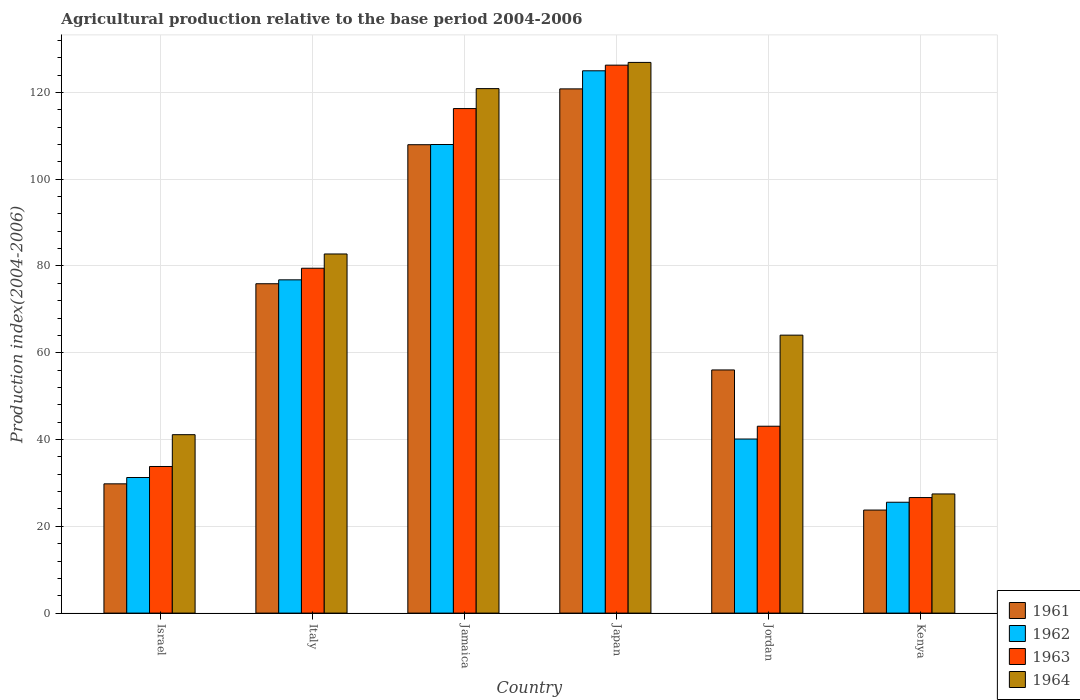How many different coloured bars are there?
Your answer should be very brief. 4. How many bars are there on the 1st tick from the left?
Your response must be concise. 4. How many bars are there on the 3rd tick from the right?
Give a very brief answer. 4. In how many cases, is the number of bars for a given country not equal to the number of legend labels?
Provide a succinct answer. 0. What is the agricultural production index in 1963 in Kenya?
Ensure brevity in your answer.  26.63. Across all countries, what is the maximum agricultural production index in 1963?
Your answer should be compact. 126.29. Across all countries, what is the minimum agricultural production index in 1964?
Your answer should be compact. 27.46. In which country was the agricultural production index in 1961 minimum?
Your answer should be very brief. Kenya. What is the total agricultural production index in 1964 in the graph?
Offer a very short reply. 463.21. What is the difference between the agricultural production index in 1961 in Israel and that in Jamaica?
Keep it short and to the point. -78.16. What is the difference between the agricultural production index in 1962 in Italy and the agricultural production index in 1963 in Jordan?
Make the answer very short. 33.74. What is the average agricultural production index in 1961 per country?
Provide a short and direct response. 69.04. What is the difference between the agricultural production index of/in 1962 and agricultural production index of/in 1963 in Japan?
Ensure brevity in your answer.  -1.3. What is the ratio of the agricultural production index in 1964 in Italy to that in Jamaica?
Your answer should be very brief. 0.68. Is the agricultural production index in 1962 in Jamaica less than that in Kenya?
Keep it short and to the point. No. Is the difference between the agricultural production index in 1962 in Jamaica and Japan greater than the difference between the agricultural production index in 1963 in Jamaica and Japan?
Offer a very short reply. No. What is the difference between the highest and the second highest agricultural production index in 1962?
Provide a succinct answer. -16.99. What is the difference between the highest and the lowest agricultural production index in 1964?
Offer a terse response. 99.46. In how many countries, is the agricultural production index in 1961 greater than the average agricultural production index in 1961 taken over all countries?
Ensure brevity in your answer.  3. Is the sum of the agricultural production index in 1963 in Japan and Kenya greater than the maximum agricultural production index in 1964 across all countries?
Provide a short and direct response. Yes. Is it the case that in every country, the sum of the agricultural production index in 1962 and agricultural production index in 1964 is greater than the sum of agricultural production index in 1961 and agricultural production index in 1963?
Ensure brevity in your answer.  No. What does the 4th bar from the right in Israel represents?
Ensure brevity in your answer.  1961. How many bars are there?
Offer a terse response. 24. Are all the bars in the graph horizontal?
Your answer should be very brief. No. How many countries are there in the graph?
Your answer should be very brief. 6. What is the difference between two consecutive major ticks on the Y-axis?
Your answer should be compact. 20. Does the graph contain any zero values?
Ensure brevity in your answer.  No. How many legend labels are there?
Provide a short and direct response. 4. How are the legend labels stacked?
Keep it short and to the point. Vertical. What is the title of the graph?
Provide a short and direct response. Agricultural production relative to the base period 2004-2006. Does "1970" appear as one of the legend labels in the graph?
Give a very brief answer. No. What is the label or title of the Y-axis?
Give a very brief answer. Production index(2004-2006). What is the Production index(2004-2006) in 1961 in Israel?
Offer a very short reply. 29.79. What is the Production index(2004-2006) of 1962 in Israel?
Your answer should be very brief. 31.25. What is the Production index(2004-2006) in 1963 in Israel?
Ensure brevity in your answer.  33.79. What is the Production index(2004-2006) of 1964 in Israel?
Provide a succinct answer. 41.12. What is the Production index(2004-2006) of 1961 in Italy?
Keep it short and to the point. 75.91. What is the Production index(2004-2006) in 1962 in Italy?
Offer a very short reply. 76.81. What is the Production index(2004-2006) in 1963 in Italy?
Offer a terse response. 79.48. What is the Production index(2004-2006) of 1964 in Italy?
Provide a short and direct response. 82.77. What is the Production index(2004-2006) in 1961 in Jamaica?
Your response must be concise. 107.95. What is the Production index(2004-2006) of 1962 in Jamaica?
Make the answer very short. 108. What is the Production index(2004-2006) in 1963 in Jamaica?
Your answer should be compact. 116.28. What is the Production index(2004-2006) in 1964 in Jamaica?
Provide a short and direct response. 120.88. What is the Production index(2004-2006) of 1961 in Japan?
Give a very brief answer. 120.82. What is the Production index(2004-2006) in 1962 in Japan?
Your answer should be compact. 124.99. What is the Production index(2004-2006) in 1963 in Japan?
Offer a terse response. 126.29. What is the Production index(2004-2006) of 1964 in Japan?
Give a very brief answer. 126.92. What is the Production index(2004-2006) of 1961 in Jordan?
Provide a succinct answer. 56.04. What is the Production index(2004-2006) in 1962 in Jordan?
Offer a very short reply. 40.12. What is the Production index(2004-2006) in 1963 in Jordan?
Ensure brevity in your answer.  43.07. What is the Production index(2004-2006) of 1964 in Jordan?
Make the answer very short. 64.06. What is the Production index(2004-2006) of 1961 in Kenya?
Provide a short and direct response. 23.75. What is the Production index(2004-2006) of 1962 in Kenya?
Offer a terse response. 25.55. What is the Production index(2004-2006) in 1963 in Kenya?
Offer a very short reply. 26.63. What is the Production index(2004-2006) of 1964 in Kenya?
Your response must be concise. 27.46. Across all countries, what is the maximum Production index(2004-2006) in 1961?
Your answer should be very brief. 120.82. Across all countries, what is the maximum Production index(2004-2006) of 1962?
Offer a very short reply. 124.99. Across all countries, what is the maximum Production index(2004-2006) of 1963?
Make the answer very short. 126.29. Across all countries, what is the maximum Production index(2004-2006) in 1964?
Give a very brief answer. 126.92. Across all countries, what is the minimum Production index(2004-2006) of 1961?
Your response must be concise. 23.75. Across all countries, what is the minimum Production index(2004-2006) of 1962?
Ensure brevity in your answer.  25.55. Across all countries, what is the minimum Production index(2004-2006) in 1963?
Keep it short and to the point. 26.63. Across all countries, what is the minimum Production index(2004-2006) of 1964?
Give a very brief answer. 27.46. What is the total Production index(2004-2006) of 1961 in the graph?
Your answer should be compact. 414.26. What is the total Production index(2004-2006) of 1962 in the graph?
Offer a terse response. 406.72. What is the total Production index(2004-2006) of 1963 in the graph?
Offer a very short reply. 425.54. What is the total Production index(2004-2006) in 1964 in the graph?
Make the answer very short. 463.21. What is the difference between the Production index(2004-2006) in 1961 in Israel and that in Italy?
Your response must be concise. -46.12. What is the difference between the Production index(2004-2006) of 1962 in Israel and that in Italy?
Offer a terse response. -45.56. What is the difference between the Production index(2004-2006) in 1963 in Israel and that in Italy?
Your answer should be very brief. -45.69. What is the difference between the Production index(2004-2006) in 1964 in Israel and that in Italy?
Provide a succinct answer. -41.65. What is the difference between the Production index(2004-2006) in 1961 in Israel and that in Jamaica?
Your response must be concise. -78.16. What is the difference between the Production index(2004-2006) in 1962 in Israel and that in Jamaica?
Offer a terse response. -76.75. What is the difference between the Production index(2004-2006) of 1963 in Israel and that in Jamaica?
Offer a terse response. -82.49. What is the difference between the Production index(2004-2006) of 1964 in Israel and that in Jamaica?
Provide a succinct answer. -79.76. What is the difference between the Production index(2004-2006) in 1961 in Israel and that in Japan?
Give a very brief answer. -91.03. What is the difference between the Production index(2004-2006) of 1962 in Israel and that in Japan?
Give a very brief answer. -93.74. What is the difference between the Production index(2004-2006) of 1963 in Israel and that in Japan?
Give a very brief answer. -92.5. What is the difference between the Production index(2004-2006) of 1964 in Israel and that in Japan?
Provide a succinct answer. -85.8. What is the difference between the Production index(2004-2006) in 1961 in Israel and that in Jordan?
Ensure brevity in your answer.  -26.25. What is the difference between the Production index(2004-2006) in 1962 in Israel and that in Jordan?
Keep it short and to the point. -8.87. What is the difference between the Production index(2004-2006) of 1963 in Israel and that in Jordan?
Provide a short and direct response. -9.28. What is the difference between the Production index(2004-2006) in 1964 in Israel and that in Jordan?
Your response must be concise. -22.94. What is the difference between the Production index(2004-2006) in 1961 in Israel and that in Kenya?
Ensure brevity in your answer.  6.04. What is the difference between the Production index(2004-2006) in 1963 in Israel and that in Kenya?
Your response must be concise. 7.16. What is the difference between the Production index(2004-2006) in 1964 in Israel and that in Kenya?
Offer a terse response. 13.66. What is the difference between the Production index(2004-2006) of 1961 in Italy and that in Jamaica?
Ensure brevity in your answer.  -32.04. What is the difference between the Production index(2004-2006) of 1962 in Italy and that in Jamaica?
Provide a succinct answer. -31.19. What is the difference between the Production index(2004-2006) in 1963 in Italy and that in Jamaica?
Provide a succinct answer. -36.8. What is the difference between the Production index(2004-2006) in 1964 in Italy and that in Jamaica?
Your answer should be compact. -38.11. What is the difference between the Production index(2004-2006) of 1961 in Italy and that in Japan?
Provide a succinct answer. -44.91. What is the difference between the Production index(2004-2006) of 1962 in Italy and that in Japan?
Your answer should be very brief. -48.18. What is the difference between the Production index(2004-2006) in 1963 in Italy and that in Japan?
Offer a terse response. -46.81. What is the difference between the Production index(2004-2006) of 1964 in Italy and that in Japan?
Keep it short and to the point. -44.15. What is the difference between the Production index(2004-2006) of 1961 in Italy and that in Jordan?
Your response must be concise. 19.87. What is the difference between the Production index(2004-2006) of 1962 in Italy and that in Jordan?
Offer a very short reply. 36.69. What is the difference between the Production index(2004-2006) in 1963 in Italy and that in Jordan?
Your response must be concise. 36.41. What is the difference between the Production index(2004-2006) in 1964 in Italy and that in Jordan?
Your answer should be very brief. 18.71. What is the difference between the Production index(2004-2006) in 1961 in Italy and that in Kenya?
Give a very brief answer. 52.16. What is the difference between the Production index(2004-2006) in 1962 in Italy and that in Kenya?
Your response must be concise. 51.26. What is the difference between the Production index(2004-2006) in 1963 in Italy and that in Kenya?
Provide a short and direct response. 52.85. What is the difference between the Production index(2004-2006) of 1964 in Italy and that in Kenya?
Your answer should be very brief. 55.31. What is the difference between the Production index(2004-2006) of 1961 in Jamaica and that in Japan?
Provide a succinct answer. -12.87. What is the difference between the Production index(2004-2006) of 1962 in Jamaica and that in Japan?
Your answer should be very brief. -16.99. What is the difference between the Production index(2004-2006) of 1963 in Jamaica and that in Japan?
Give a very brief answer. -10.01. What is the difference between the Production index(2004-2006) of 1964 in Jamaica and that in Japan?
Your answer should be compact. -6.04. What is the difference between the Production index(2004-2006) of 1961 in Jamaica and that in Jordan?
Give a very brief answer. 51.91. What is the difference between the Production index(2004-2006) of 1962 in Jamaica and that in Jordan?
Keep it short and to the point. 67.88. What is the difference between the Production index(2004-2006) in 1963 in Jamaica and that in Jordan?
Keep it short and to the point. 73.21. What is the difference between the Production index(2004-2006) in 1964 in Jamaica and that in Jordan?
Ensure brevity in your answer.  56.82. What is the difference between the Production index(2004-2006) of 1961 in Jamaica and that in Kenya?
Provide a short and direct response. 84.2. What is the difference between the Production index(2004-2006) in 1962 in Jamaica and that in Kenya?
Ensure brevity in your answer.  82.45. What is the difference between the Production index(2004-2006) in 1963 in Jamaica and that in Kenya?
Keep it short and to the point. 89.65. What is the difference between the Production index(2004-2006) in 1964 in Jamaica and that in Kenya?
Your response must be concise. 93.42. What is the difference between the Production index(2004-2006) in 1961 in Japan and that in Jordan?
Your answer should be compact. 64.78. What is the difference between the Production index(2004-2006) of 1962 in Japan and that in Jordan?
Ensure brevity in your answer.  84.87. What is the difference between the Production index(2004-2006) of 1963 in Japan and that in Jordan?
Provide a short and direct response. 83.22. What is the difference between the Production index(2004-2006) in 1964 in Japan and that in Jordan?
Keep it short and to the point. 62.86. What is the difference between the Production index(2004-2006) in 1961 in Japan and that in Kenya?
Offer a very short reply. 97.07. What is the difference between the Production index(2004-2006) in 1962 in Japan and that in Kenya?
Give a very brief answer. 99.44. What is the difference between the Production index(2004-2006) in 1963 in Japan and that in Kenya?
Offer a terse response. 99.66. What is the difference between the Production index(2004-2006) of 1964 in Japan and that in Kenya?
Ensure brevity in your answer.  99.46. What is the difference between the Production index(2004-2006) in 1961 in Jordan and that in Kenya?
Your answer should be very brief. 32.29. What is the difference between the Production index(2004-2006) in 1962 in Jordan and that in Kenya?
Offer a terse response. 14.57. What is the difference between the Production index(2004-2006) in 1963 in Jordan and that in Kenya?
Offer a terse response. 16.44. What is the difference between the Production index(2004-2006) of 1964 in Jordan and that in Kenya?
Make the answer very short. 36.6. What is the difference between the Production index(2004-2006) in 1961 in Israel and the Production index(2004-2006) in 1962 in Italy?
Offer a very short reply. -47.02. What is the difference between the Production index(2004-2006) in 1961 in Israel and the Production index(2004-2006) in 1963 in Italy?
Provide a short and direct response. -49.69. What is the difference between the Production index(2004-2006) of 1961 in Israel and the Production index(2004-2006) of 1964 in Italy?
Your answer should be compact. -52.98. What is the difference between the Production index(2004-2006) of 1962 in Israel and the Production index(2004-2006) of 1963 in Italy?
Your answer should be very brief. -48.23. What is the difference between the Production index(2004-2006) in 1962 in Israel and the Production index(2004-2006) in 1964 in Italy?
Offer a very short reply. -51.52. What is the difference between the Production index(2004-2006) of 1963 in Israel and the Production index(2004-2006) of 1964 in Italy?
Your answer should be compact. -48.98. What is the difference between the Production index(2004-2006) in 1961 in Israel and the Production index(2004-2006) in 1962 in Jamaica?
Your answer should be compact. -78.21. What is the difference between the Production index(2004-2006) in 1961 in Israel and the Production index(2004-2006) in 1963 in Jamaica?
Keep it short and to the point. -86.49. What is the difference between the Production index(2004-2006) in 1961 in Israel and the Production index(2004-2006) in 1964 in Jamaica?
Ensure brevity in your answer.  -91.09. What is the difference between the Production index(2004-2006) of 1962 in Israel and the Production index(2004-2006) of 1963 in Jamaica?
Give a very brief answer. -85.03. What is the difference between the Production index(2004-2006) in 1962 in Israel and the Production index(2004-2006) in 1964 in Jamaica?
Offer a terse response. -89.63. What is the difference between the Production index(2004-2006) in 1963 in Israel and the Production index(2004-2006) in 1964 in Jamaica?
Make the answer very short. -87.09. What is the difference between the Production index(2004-2006) in 1961 in Israel and the Production index(2004-2006) in 1962 in Japan?
Provide a succinct answer. -95.2. What is the difference between the Production index(2004-2006) in 1961 in Israel and the Production index(2004-2006) in 1963 in Japan?
Your response must be concise. -96.5. What is the difference between the Production index(2004-2006) of 1961 in Israel and the Production index(2004-2006) of 1964 in Japan?
Your answer should be very brief. -97.13. What is the difference between the Production index(2004-2006) in 1962 in Israel and the Production index(2004-2006) in 1963 in Japan?
Provide a succinct answer. -95.04. What is the difference between the Production index(2004-2006) in 1962 in Israel and the Production index(2004-2006) in 1964 in Japan?
Provide a succinct answer. -95.67. What is the difference between the Production index(2004-2006) of 1963 in Israel and the Production index(2004-2006) of 1964 in Japan?
Provide a succinct answer. -93.13. What is the difference between the Production index(2004-2006) of 1961 in Israel and the Production index(2004-2006) of 1962 in Jordan?
Your response must be concise. -10.33. What is the difference between the Production index(2004-2006) of 1961 in Israel and the Production index(2004-2006) of 1963 in Jordan?
Offer a terse response. -13.28. What is the difference between the Production index(2004-2006) in 1961 in Israel and the Production index(2004-2006) in 1964 in Jordan?
Your response must be concise. -34.27. What is the difference between the Production index(2004-2006) of 1962 in Israel and the Production index(2004-2006) of 1963 in Jordan?
Provide a short and direct response. -11.82. What is the difference between the Production index(2004-2006) in 1962 in Israel and the Production index(2004-2006) in 1964 in Jordan?
Provide a short and direct response. -32.81. What is the difference between the Production index(2004-2006) in 1963 in Israel and the Production index(2004-2006) in 1964 in Jordan?
Your answer should be compact. -30.27. What is the difference between the Production index(2004-2006) in 1961 in Israel and the Production index(2004-2006) in 1962 in Kenya?
Give a very brief answer. 4.24. What is the difference between the Production index(2004-2006) of 1961 in Israel and the Production index(2004-2006) of 1963 in Kenya?
Make the answer very short. 3.16. What is the difference between the Production index(2004-2006) in 1961 in Israel and the Production index(2004-2006) in 1964 in Kenya?
Your answer should be very brief. 2.33. What is the difference between the Production index(2004-2006) in 1962 in Israel and the Production index(2004-2006) in 1963 in Kenya?
Your response must be concise. 4.62. What is the difference between the Production index(2004-2006) of 1962 in Israel and the Production index(2004-2006) of 1964 in Kenya?
Ensure brevity in your answer.  3.79. What is the difference between the Production index(2004-2006) in 1963 in Israel and the Production index(2004-2006) in 1964 in Kenya?
Keep it short and to the point. 6.33. What is the difference between the Production index(2004-2006) of 1961 in Italy and the Production index(2004-2006) of 1962 in Jamaica?
Your answer should be very brief. -32.09. What is the difference between the Production index(2004-2006) of 1961 in Italy and the Production index(2004-2006) of 1963 in Jamaica?
Your answer should be very brief. -40.37. What is the difference between the Production index(2004-2006) in 1961 in Italy and the Production index(2004-2006) in 1964 in Jamaica?
Your response must be concise. -44.97. What is the difference between the Production index(2004-2006) in 1962 in Italy and the Production index(2004-2006) in 1963 in Jamaica?
Offer a very short reply. -39.47. What is the difference between the Production index(2004-2006) of 1962 in Italy and the Production index(2004-2006) of 1964 in Jamaica?
Provide a succinct answer. -44.07. What is the difference between the Production index(2004-2006) of 1963 in Italy and the Production index(2004-2006) of 1964 in Jamaica?
Give a very brief answer. -41.4. What is the difference between the Production index(2004-2006) in 1961 in Italy and the Production index(2004-2006) in 1962 in Japan?
Give a very brief answer. -49.08. What is the difference between the Production index(2004-2006) of 1961 in Italy and the Production index(2004-2006) of 1963 in Japan?
Your response must be concise. -50.38. What is the difference between the Production index(2004-2006) of 1961 in Italy and the Production index(2004-2006) of 1964 in Japan?
Your answer should be compact. -51.01. What is the difference between the Production index(2004-2006) of 1962 in Italy and the Production index(2004-2006) of 1963 in Japan?
Provide a succinct answer. -49.48. What is the difference between the Production index(2004-2006) in 1962 in Italy and the Production index(2004-2006) in 1964 in Japan?
Provide a short and direct response. -50.11. What is the difference between the Production index(2004-2006) of 1963 in Italy and the Production index(2004-2006) of 1964 in Japan?
Give a very brief answer. -47.44. What is the difference between the Production index(2004-2006) of 1961 in Italy and the Production index(2004-2006) of 1962 in Jordan?
Give a very brief answer. 35.79. What is the difference between the Production index(2004-2006) in 1961 in Italy and the Production index(2004-2006) in 1963 in Jordan?
Provide a short and direct response. 32.84. What is the difference between the Production index(2004-2006) in 1961 in Italy and the Production index(2004-2006) in 1964 in Jordan?
Offer a terse response. 11.85. What is the difference between the Production index(2004-2006) in 1962 in Italy and the Production index(2004-2006) in 1963 in Jordan?
Your response must be concise. 33.74. What is the difference between the Production index(2004-2006) in 1962 in Italy and the Production index(2004-2006) in 1964 in Jordan?
Provide a short and direct response. 12.75. What is the difference between the Production index(2004-2006) in 1963 in Italy and the Production index(2004-2006) in 1964 in Jordan?
Provide a short and direct response. 15.42. What is the difference between the Production index(2004-2006) in 1961 in Italy and the Production index(2004-2006) in 1962 in Kenya?
Ensure brevity in your answer.  50.36. What is the difference between the Production index(2004-2006) of 1961 in Italy and the Production index(2004-2006) of 1963 in Kenya?
Offer a very short reply. 49.28. What is the difference between the Production index(2004-2006) in 1961 in Italy and the Production index(2004-2006) in 1964 in Kenya?
Your response must be concise. 48.45. What is the difference between the Production index(2004-2006) in 1962 in Italy and the Production index(2004-2006) in 1963 in Kenya?
Ensure brevity in your answer.  50.18. What is the difference between the Production index(2004-2006) in 1962 in Italy and the Production index(2004-2006) in 1964 in Kenya?
Give a very brief answer. 49.35. What is the difference between the Production index(2004-2006) of 1963 in Italy and the Production index(2004-2006) of 1964 in Kenya?
Provide a short and direct response. 52.02. What is the difference between the Production index(2004-2006) of 1961 in Jamaica and the Production index(2004-2006) of 1962 in Japan?
Make the answer very short. -17.04. What is the difference between the Production index(2004-2006) of 1961 in Jamaica and the Production index(2004-2006) of 1963 in Japan?
Give a very brief answer. -18.34. What is the difference between the Production index(2004-2006) of 1961 in Jamaica and the Production index(2004-2006) of 1964 in Japan?
Offer a terse response. -18.97. What is the difference between the Production index(2004-2006) in 1962 in Jamaica and the Production index(2004-2006) in 1963 in Japan?
Your answer should be compact. -18.29. What is the difference between the Production index(2004-2006) in 1962 in Jamaica and the Production index(2004-2006) in 1964 in Japan?
Your answer should be compact. -18.92. What is the difference between the Production index(2004-2006) in 1963 in Jamaica and the Production index(2004-2006) in 1964 in Japan?
Offer a terse response. -10.64. What is the difference between the Production index(2004-2006) of 1961 in Jamaica and the Production index(2004-2006) of 1962 in Jordan?
Ensure brevity in your answer.  67.83. What is the difference between the Production index(2004-2006) in 1961 in Jamaica and the Production index(2004-2006) in 1963 in Jordan?
Ensure brevity in your answer.  64.88. What is the difference between the Production index(2004-2006) of 1961 in Jamaica and the Production index(2004-2006) of 1964 in Jordan?
Provide a short and direct response. 43.89. What is the difference between the Production index(2004-2006) of 1962 in Jamaica and the Production index(2004-2006) of 1963 in Jordan?
Offer a very short reply. 64.93. What is the difference between the Production index(2004-2006) in 1962 in Jamaica and the Production index(2004-2006) in 1964 in Jordan?
Make the answer very short. 43.94. What is the difference between the Production index(2004-2006) in 1963 in Jamaica and the Production index(2004-2006) in 1964 in Jordan?
Your answer should be very brief. 52.22. What is the difference between the Production index(2004-2006) in 1961 in Jamaica and the Production index(2004-2006) in 1962 in Kenya?
Offer a terse response. 82.4. What is the difference between the Production index(2004-2006) in 1961 in Jamaica and the Production index(2004-2006) in 1963 in Kenya?
Keep it short and to the point. 81.32. What is the difference between the Production index(2004-2006) in 1961 in Jamaica and the Production index(2004-2006) in 1964 in Kenya?
Your response must be concise. 80.49. What is the difference between the Production index(2004-2006) in 1962 in Jamaica and the Production index(2004-2006) in 1963 in Kenya?
Your answer should be compact. 81.37. What is the difference between the Production index(2004-2006) of 1962 in Jamaica and the Production index(2004-2006) of 1964 in Kenya?
Your answer should be compact. 80.54. What is the difference between the Production index(2004-2006) in 1963 in Jamaica and the Production index(2004-2006) in 1964 in Kenya?
Provide a short and direct response. 88.82. What is the difference between the Production index(2004-2006) of 1961 in Japan and the Production index(2004-2006) of 1962 in Jordan?
Give a very brief answer. 80.7. What is the difference between the Production index(2004-2006) in 1961 in Japan and the Production index(2004-2006) in 1963 in Jordan?
Offer a terse response. 77.75. What is the difference between the Production index(2004-2006) of 1961 in Japan and the Production index(2004-2006) of 1964 in Jordan?
Provide a short and direct response. 56.76. What is the difference between the Production index(2004-2006) in 1962 in Japan and the Production index(2004-2006) in 1963 in Jordan?
Offer a terse response. 81.92. What is the difference between the Production index(2004-2006) in 1962 in Japan and the Production index(2004-2006) in 1964 in Jordan?
Provide a short and direct response. 60.93. What is the difference between the Production index(2004-2006) of 1963 in Japan and the Production index(2004-2006) of 1964 in Jordan?
Make the answer very short. 62.23. What is the difference between the Production index(2004-2006) of 1961 in Japan and the Production index(2004-2006) of 1962 in Kenya?
Your answer should be very brief. 95.27. What is the difference between the Production index(2004-2006) of 1961 in Japan and the Production index(2004-2006) of 1963 in Kenya?
Your response must be concise. 94.19. What is the difference between the Production index(2004-2006) in 1961 in Japan and the Production index(2004-2006) in 1964 in Kenya?
Your response must be concise. 93.36. What is the difference between the Production index(2004-2006) of 1962 in Japan and the Production index(2004-2006) of 1963 in Kenya?
Keep it short and to the point. 98.36. What is the difference between the Production index(2004-2006) of 1962 in Japan and the Production index(2004-2006) of 1964 in Kenya?
Provide a succinct answer. 97.53. What is the difference between the Production index(2004-2006) of 1963 in Japan and the Production index(2004-2006) of 1964 in Kenya?
Your answer should be compact. 98.83. What is the difference between the Production index(2004-2006) of 1961 in Jordan and the Production index(2004-2006) of 1962 in Kenya?
Provide a succinct answer. 30.49. What is the difference between the Production index(2004-2006) of 1961 in Jordan and the Production index(2004-2006) of 1963 in Kenya?
Give a very brief answer. 29.41. What is the difference between the Production index(2004-2006) of 1961 in Jordan and the Production index(2004-2006) of 1964 in Kenya?
Keep it short and to the point. 28.58. What is the difference between the Production index(2004-2006) of 1962 in Jordan and the Production index(2004-2006) of 1963 in Kenya?
Offer a very short reply. 13.49. What is the difference between the Production index(2004-2006) in 1962 in Jordan and the Production index(2004-2006) in 1964 in Kenya?
Your answer should be very brief. 12.66. What is the difference between the Production index(2004-2006) in 1963 in Jordan and the Production index(2004-2006) in 1964 in Kenya?
Make the answer very short. 15.61. What is the average Production index(2004-2006) in 1961 per country?
Make the answer very short. 69.04. What is the average Production index(2004-2006) in 1962 per country?
Provide a succinct answer. 67.79. What is the average Production index(2004-2006) of 1963 per country?
Offer a terse response. 70.92. What is the average Production index(2004-2006) of 1964 per country?
Offer a very short reply. 77.2. What is the difference between the Production index(2004-2006) of 1961 and Production index(2004-2006) of 1962 in Israel?
Your response must be concise. -1.46. What is the difference between the Production index(2004-2006) of 1961 and Production index(2004-2006) of 1963 in Israel?
Your answer should be very brief. -4. What is the difference between the Production index(2004-2006) of 1961 and Production index(2004-2006) of 1964 in Israel?
Your answer should be compact. -11.33. What is the difference between the Production index(2004-2006) in 1962 and Production index(2004-2006) in 1963 in Israel?
Make the answer very short. -2.54. What is the difference between the Production index(2004-2006) in 1962 and Production index(2004-2006) in 1964 in Israel?
Ensure brevity in your answer.  -9.87. What is the difference between the Production index(2004-2006) in 1963 and Production index(2004-2006) in 1964 in Israel?
Provide a succinct answer. -7.33. What is the difference between the Production index(2004-2006) of 1961 and Production index(2004-2006) of 1963 in Italy?
Offer a very short reply. -3.57. What is the difference between the Production index(2004-2006) of 1961 and Production index(2004-2006) of 1964 in Italy?
Make the answer very short. -6.86. What is the difference between the Production index(2004-2006) in 1962 and Production index(2004-2006) in 1963 in Italy?
Provide a succinct answer. -2.67. What is the difference between the Production index(2004-2006) in 1962 and Production index(2004-2006) in 1964 in Italy?
Offer a very short reply. -5.96. What is the difference between the Production index(2004-2006) of 1963 and Production index(2004-2006) of 1964 in Italy?
Make the answer very short. -3.29. What is the difference between the Production index(2004-2006) in 1961 and Production index(2004-2006) in 1962 in Jamaica?
Provide a succinct answer. -0.05. What is the difference between the Production index(2004-2006) in 1961 and Production index(2004-2006) in 1963 in Jamaica?
Your answer should be compact. -8.33. What is the difference between the Production index(2004-2006) in 1961 and Production index(2004-2006) in 1964 in Jamaica?
Your response must be concise. -12.93. What is the difference between the Production index(2004-2006) in 1962 and Production index(2004-2006) in 1963 in Jamaica?
Offer a very short reply. -8.28. What is the difference between the Production index(2004-2006) of 1962 and Production index(2004-2006) of 1964 in Jamaica?
Your response must be concise. -12.88. What is the difference between the Production index(2004-2006) of 1961 and Production index(2004-2006) of 1962 in Japan?
Your answer should be compact. -4.17. What is the difference between the Production index(2004-2006) of 1961 and Production index(2004-2006) of 1963 in Japan?
Provide a succinct answer. -5.47. What is the difference between the Production index(2004-2006) of 1961 and Production index(2004-2006) of 1964 in Japan?
Your response must be concise. -6.1. What is the difference between the Production index(2004-2006) in 1962 and Production index(2004-2006) in 1964 in Japan?
Offer a terse response. -1.93. What is the difference between the Production index(2004-2006) in 1963 and Production index(2004-2006) in 1964 in Japan?
Offer a terse response. -0.63. What is the difference between the Production index(2004-2006) in 1961 and Production index(2004-2006) in 1962 in Jordan?
Your answer should be compact. 15.92. What is the difference between the Production index(2004-2006) of 1961 and Production index(2004-2006) of 1963 in Jordan?
Your answer should be very brief. 12.97. What is the difference between the Production index(2004-2006) of 1961 and Production index(2004-2006) of 1964 in Jordan?
Your response must be concise. -8.02. What is the difference between the Production index(2004-2006) of 1962 and Production index(2004-2006) of 1963 in Jordan?
Your answer should be compact. -2.95. What is the difference between the Production index(2004-2006) of 1962 and Production index(2004-2006) of 1964 in Jordan?
Offer a terse response. -23.94. What is the difference between the Production index(2004-2006) in 1963 and Production index(2004-2006) in 1964 in Jordan?
Provide a short and direct response. -20.99. What is the difference between the Production index(2004-2006) in 1961 and Production index(2004-2006) in 1963 in Kenya?
Provide a succinct answer. -2.88. What is the difference between the Production index(2004-2006) in 1961 and Production index(2004-2006) in 1964 in Kenya?
Your answer should be compact. -3.71. What is the difference between the Production index(2004-2006) in 1962 and Production index(2004-2006) in 1963 in Kenya?
Your answer should be very brief. -1.08. What is the difference between the Production index(2004-2006) in 1962 and Production index(2004-2006) in 1964 in Kenya?
Keep it short and to the point. -1.91. What is the difference between the Production index(2004-2006) of 1963 and Production index(2004-2006) of 1964 in Kenya?
Give a very brief answer. -0.83. What is the ratio of the Production index(2004-2006) in 1961 in Israel to that in Italy?
Provide a short and direct response. 0.39. What is the ratio of the Production index(2004-2006) in 1962 in Israel to that in Italy?
Provide a short and direct response. 0.41. What is the ratio of the Production index(2004-2006) in 1963 in Israel to that in Italy?
Keep it short and to the point. 0.43. What is the ratio of the Production index(2004-2006) of 1964 in Israel to that in Italy?
Your answer should be very brief. 0.5. What is the ratio of the Production index(2004-2006) of 1961 in Israel to that in Jamaica?
Provide a short and direct response. 0.28. What is the ratio of the Production index(2004-2006) of 1962 in Israel to that in Jamaica?
Offer a terse response. 0.29. What is the ratio of the Production index(2004-2006) of 1963 in Israel to that in Jamaica?
Provide a succinct answer. 0.29. What is the ratio of the Production index(2004-2006) of 1964 in Israel to that in Jamaica?
Give a very brief answer. 0.34. What is the ratio of the Production index(2004-2006) of 1961 in Israel to that in Japan?
Give a very brief answer. 0.25. What is the ratio of the Production index(2004-2006) of 1963 in Israel to that in Japan?
Keep it short and to the point. 0.27. What is the ratio of the Production index(2004-2006) in 1964 in Israel to that in Japan?
Your answer should be compact. 0.32. What is the ratio of the Production index(2004-2006) of 1961 in Israel to that in Jordan?
Your response must be concise. 0.53. What is the ratio of the Production index(2004-2006) of 1962 in Israel to that in Jordan?
Keep it short and to the point. 0.78. What is the ratio of the Production index(2004-2006) of 1963 in Israel to that in Jordan?
Make the answer very short. 0.78. What is the ratio of the Production index(2004-2006) of 1964 in Israel to that in Jordan?
Offer a terse response. 0.64. What is the ratio of the Production index(2004-2006) of 1961 in Israel to that in Kenya?
Your response must be concise. 1.25. What is the ratio of the Production index(2004-2006) of 1962 in Israel to that in Kenya?
Your answer should be compact. 1.22. What is the ratio of the Production index(2004-2006) of 1963 in Israel to that in Kenya?
Provide a short and direct response. 1.27. What is the ratio of the Production index(2004-2006) of 1964 in Israel to that in Kenya?
Give a very brief answer. 1.5. What is the ratio of the Production index(2004-2006) of 1961 in Italy to that in Jamaica?
Your response must be concise. 0.7. What is the ratio of the Production index(2004-2006) in 1962 in Italy to that in Jamaica?
Keep it short and to the point. 0.71. What is the ratio of the Production index(2004-2006) in 1963 in Italy to that in Jamaica?
Provide a short and direct response. 0.68. What is the ratio of the Production index(2004-2006) of 1964 in Italy to that in Jamaica?
Keep it short and to the point. 0.68. What is the ratio of the Production index(2004-2006) in 1961 in Italy to that in Japan?
Your answer should be compact. 0.63. What is the ratio of the Production index(2004-2006) in 1962 in Italy to that in Japan?
Ensure brevity in your answer.  0.61. What is the ratio of the Production index(2004-2006) of 1963 in Italy to that in Japan?
Your answer should be very brief. 0.63. What is the ratio of the Production index(2004-2006) in 1964 in Italy to that in Japan?
Make the answer very short. 0.65. What is the ratio of the Production index(2004-2006) of 1961 in Italy to that in Jordan?
Give a very brief answer. 1.35. What is the ratio of the Production index(2004-2006) of 1962 in Italy to that in Jordan?
Make the answer very short. 1.91. What is the ratio of the Production index(2004-2006) of 1963 in Italy to that in Jordan?
Your answer should be very brief. 1.85. What is the ratio of the Production index(2004-2006) of 1964 in Italy to that in Jordan?
Your response must be concise. 1.29. What is the ratio of the Production index(2004-2006) of 1961 in Italy to that in Kenya?
Make the answer very short. 3.2. What is the ratio of the Production index(2004-2006) in 1962 in Italy to that in Kenya?
Your answer should be compact. 3.01. What is the ratio of the Production index(2004-2006) in 1963 in Italy to that in Kenya?
Your answer should be compact. 2.98. What is the ratio of the Production index(2004-2006) of 1964 in Italy to that in Kenya?
Offer a very short reply. 3.01. What is the ratio of the Production index(2004-2006) of 1961 in Jamaica to that in Japan?
Ensure brevity in your answer.  0.89. What is the ratio of the Production index(2004-2006) of 1962 in Jamaica to that in Japan?
Your response must be concise. 0.86. What is the ratio of the Production index(2004-2006) of 1963 in Jamaica to that in Japan?
Your answer should be compact. 0.92. What is the ratio of the Production index(2004-2006) in 1961 in Jamaica to that in Jordan?
Provide a succinct answer. 1.93. What is the ratio of the Production index(2004-2006) of 1962 in Jamaica to that in Jordan?
Provide a short and direct response. 2.69. What is the ratio of the Production index(2004-2006) in 1963 in Jamaica to that in Jordan?
Keep it short and to the point. 2.7. What is the ratio of the Production index(2004-2006) of 1964 in Jamaica to that in Jordan?
Provide a succinct answer. 1.89. What is the ratio of the Production index(2004-2006) of 1961 in Jamaica to that in Kenya?
Your answer should be compact. 4.55. What is the ratio of the Production index(2004-2006) in 1962 in Jamaica to that in Kenya?
Give a very brief answer. 4.23. What is the ratio of the Production index(2004-2006) of 1963 in Jamaica to that in Kenya?
Provide a short and direct response. 4.37. What is the ratio of the Production index(2004-2006) in 1964 in Jamaica to that in Kenya?
Provide a short and direct response. 4.4. What is the ratio of the Production index(2004-2006) in 1961 in Japan to that in Jordan?
Your response must be concise. 2.16. What is the ratio of the Production index(2004-2006) of 1962 in Japan to that in Jordan?
Make the answer very short. 3.12. What is the ratio of the Production index(2004-2006) of 1963 in Japan to that in Jordan?
Ensure brevity in your answer.  2.93. What is the ratio of the Production index(2004-2006) in 1964 in Japan to that in Jordan?
Ensure brevity in your answer.  1.98. What is the ratio of the Production index(2004-2006) of 1961 in Japan to that in Kenya?
Your answer should be very brief. 5.09. What is the ratio of the Production index(2004-2006) of 1962 in Japan to that in Kenya?
Your answer should be compact. 4.89. What is the ratio of the Production index(2004-2006) of 1963 in Japan to that in Kenya?
Your answer should be compact. 4.74. What is the ratio of the Production index(2004-2006) of 1964 in Japan to that in Kenya?
Offer a very short reply. 4.62. What is the ratio of the Production index(2004-2006) in 1961 in Jordan to that in Kenya?
Your answer should be very brief. 2.36. What is the ratio of the Production index(2004-2006) in 1962 in Jordan to that in Kenya?
Make the answer very short. 1.57. What is the ratio of the Production index(2004-2006) in 1963 in Jordan to that in Kenya?
Provide a short and direct response. 1.62. What is the ratio of the Production index(2004-2006) of 1964 in Jordan to that in Kenya?
Your response must be concise. 2.33. What is the difference between the highest and the second highest Production index(2004-2006) in 1961?
Your answer should be compact. 12.87. What is the difference between the highest and the second highest Production index(2004-2006) in 1962?
Your answer should be very brief. 16.99. What is the difference between the highest and the second highest Production index(2004-2006) in 1963?
Ensure brevity in your answer.  10.01. What is the difference between the highest and the second highest Production index(2004-2006) of 1964?
Your response must be concise. 6.04. What is the difference between the highest and the lowest Production index(2004-2006) in 1961?
Provide a short and direct response. 97.07. What is the difference between the highest and the lowest Production index(2004-2006) in 1962?
Offer a very short reply. 99.44. What is the difference between the highest and the lowest Production index(2004-2006) of 1963?
Provide a succinct answer. 99.66. What is the difference between the highest and the lowest Production index(2004-2006) of 1964?
Make the answer very short. 99.46. 